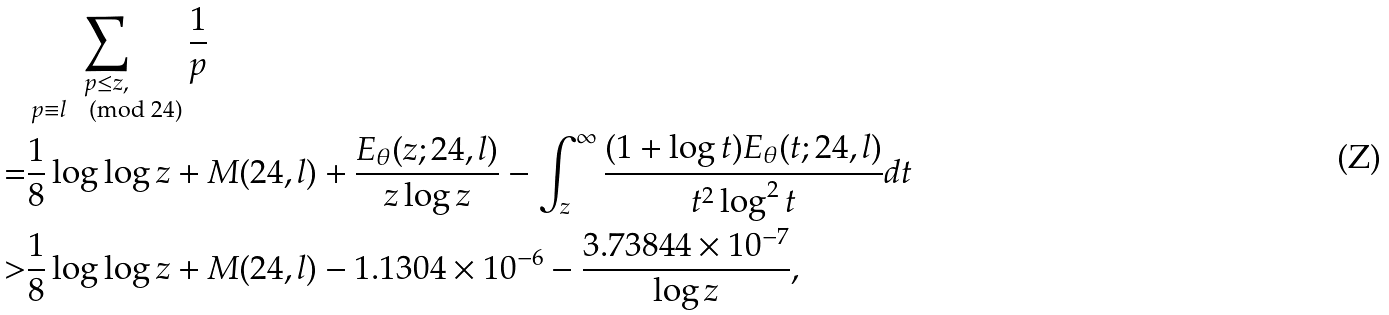Convert formula to latex. <formula><loc_0><loc_0><loc_500><loc_500>& \sum _ { \substack { p \leq z , \\ p \equiv l \pmod { 2 4 } } } \frac { 1 } { p } \\ = & \frac { 1 } { 8 } \log \log z + M ( 2 4 , l ) + \frac { E _ { \theta } ( z ; 2 4 , l ) } { z \log z } - \int _ { z } ^ { \infty } \frac { ( 1 + \log t ) E _ { \theta } ( t ; 2 4 , l ) } { t ^ { 2 } \log ^ { 2 } t } d t \\ > & \frac { 1 } { 8 } \log \log z + M ( 2 4 , l ) - 1 . 1 3 0 4 \times 1 0 ^ { - 6 } - \frac { 3 . 7 3 8 4 4 \times 1 0 ^ { - 7 } } { \log z } ,</formula> 